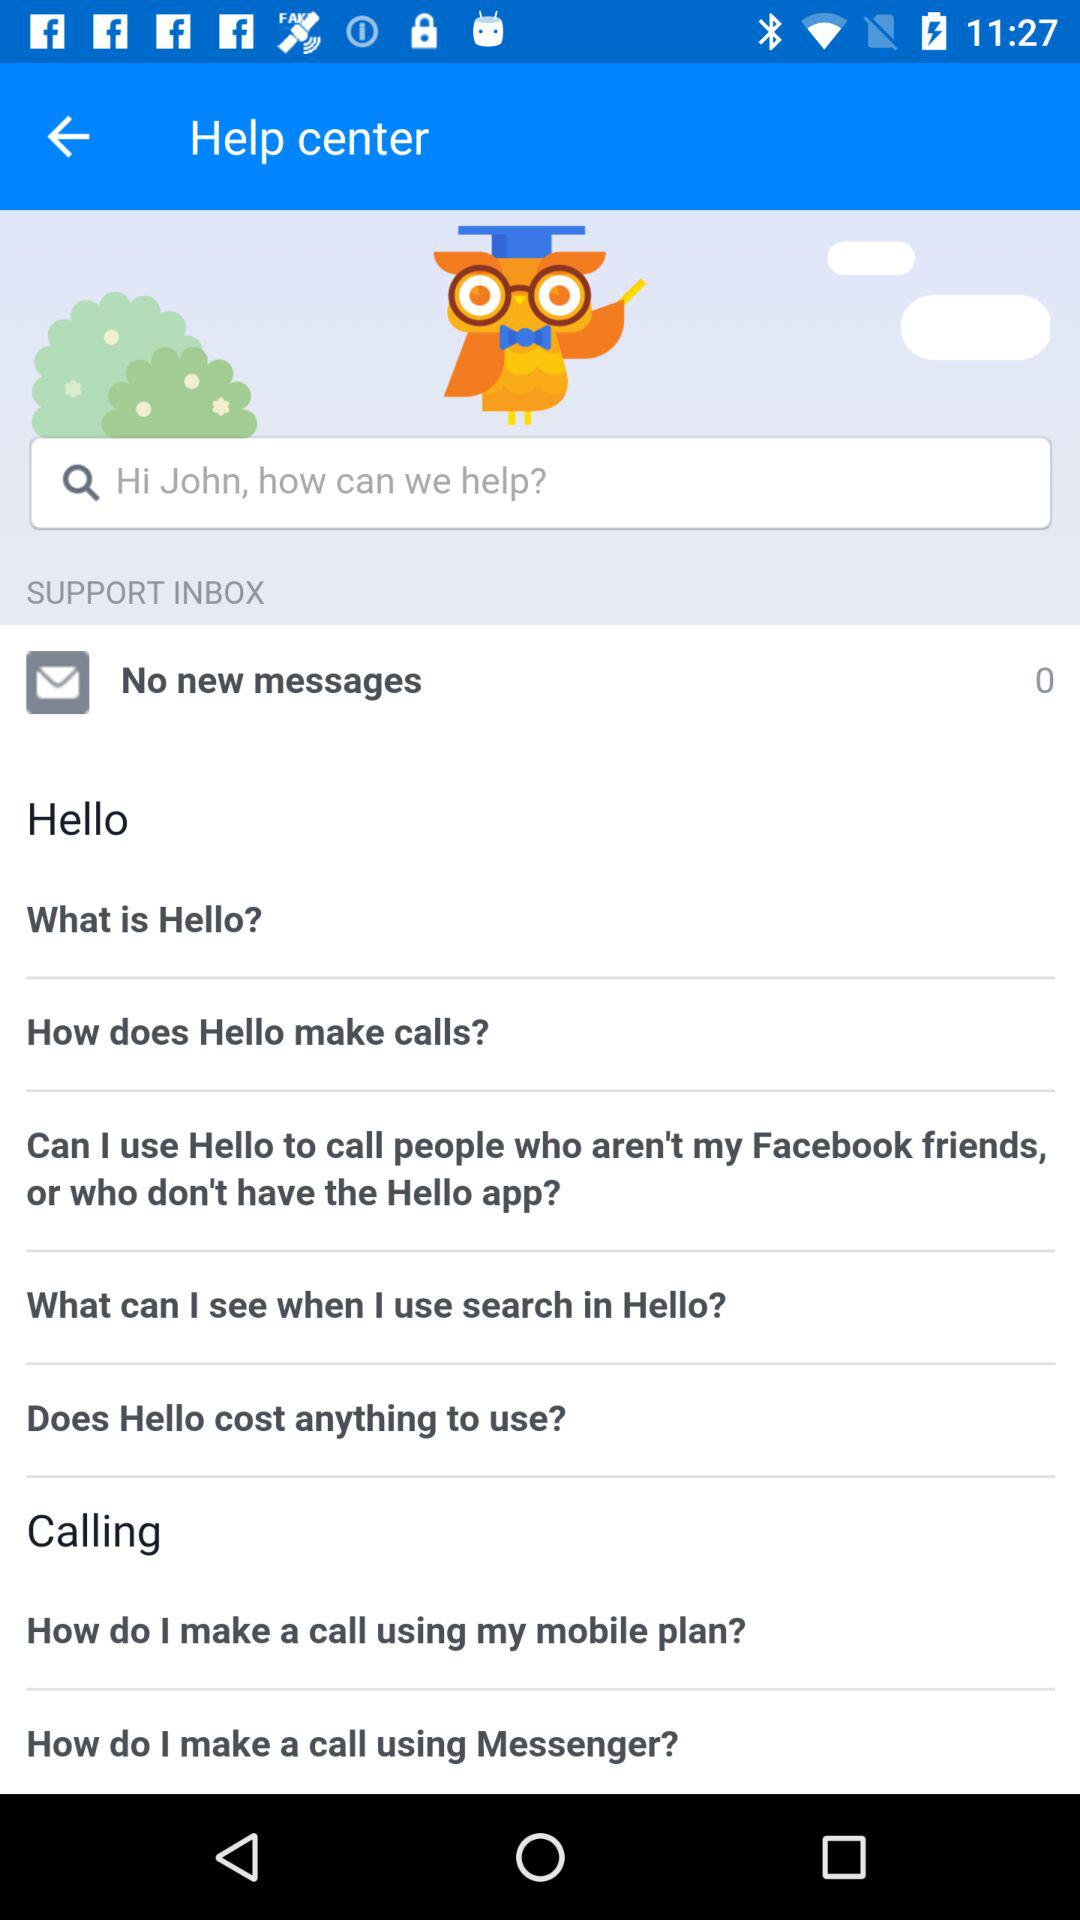What is the name of the application? The name of the application is "Hello". 